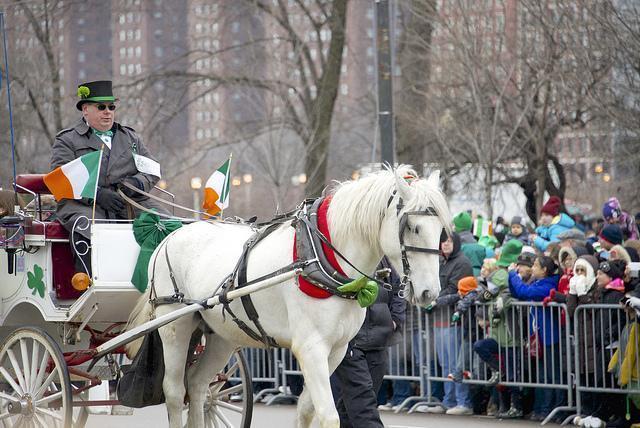What country's flag is on the white carriage?
Make your selection from the four choices given to correctly answer the question.
Options: Italy, ireland, germany, russia. Ireland. 